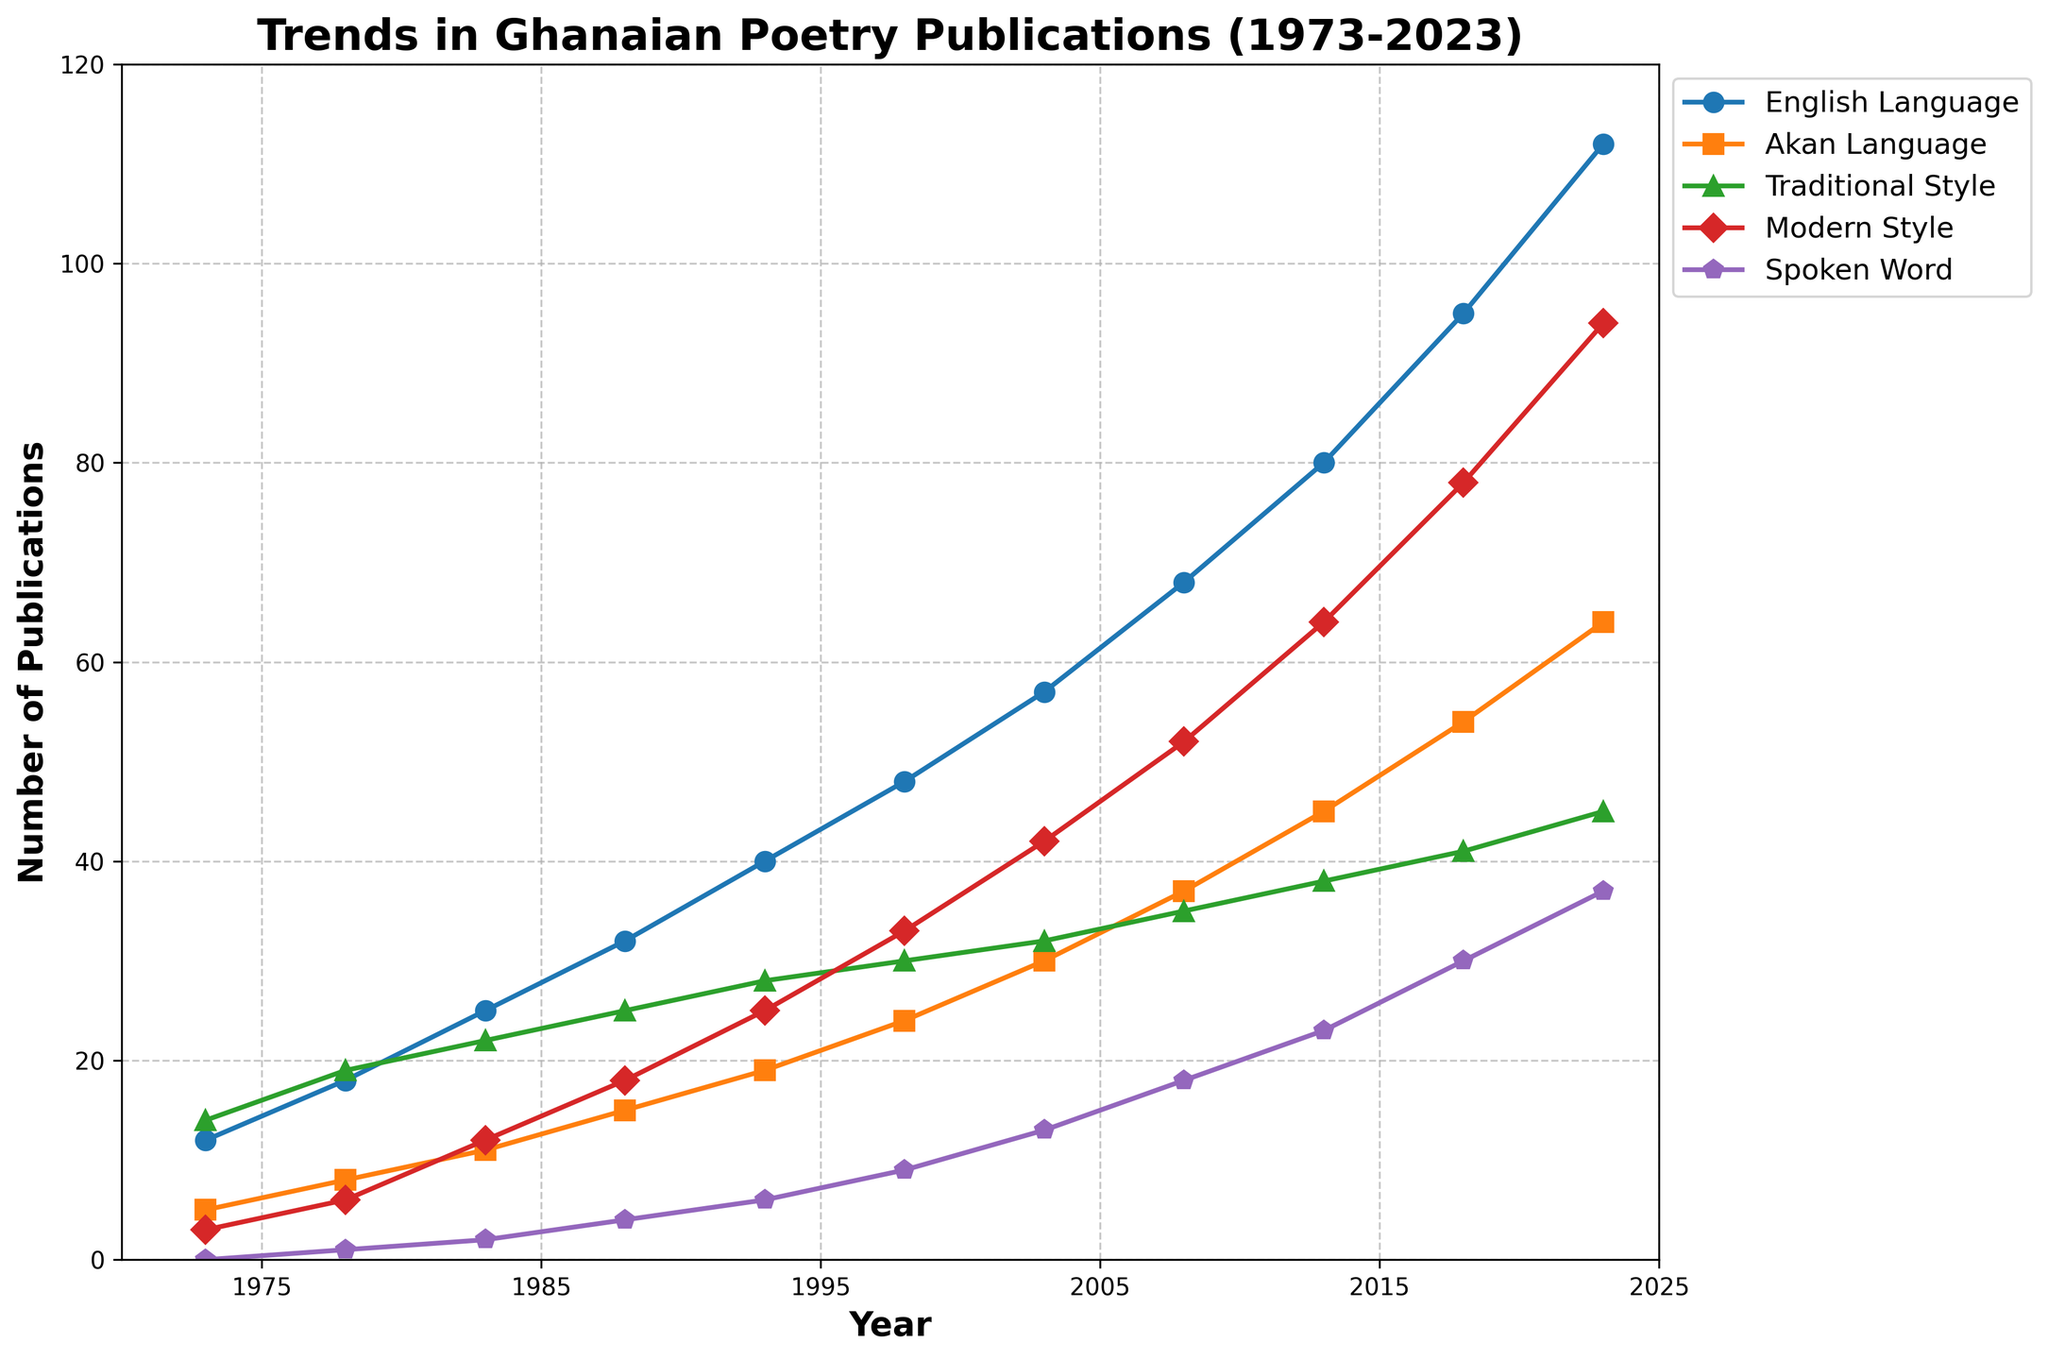What is the trend in the number of poetry publications in English from 1973 to 2023? The number of poetry publications in English shows a consistent increase over time, starting at 12 in 1973 and reaching 112 in 2023.
Answer: Continuous increase In which year did Traditional Style publications first surpass 20? Traditional Style publications surpassed 20 for the first time in 1983 with 22 publications.
Answer: 1983 What’s the difference in the number of Modern Style publications between 1993 and 2003? In 1993, there were 25 Modern Style publications, and in 2003, there were 42. The difference is 42 - 25 = 17.
Answer: 17 Which category had the smallest number of publications in 1978? The Spoken Word category had the smallest number of publications with just 1 in 1978.
Answer: Spoken Word How many more poetry publications in Modern Style were there in 2023 compared to 2013? In 2023, there were 94 Modern Style publications, and in 2013, there were 64. The difference is 94 - 64 = 30.
Answer: 30 In 2018, how many more publications were there in English compared to Akan? In 2018, there were 95 publications in English and 54 in Akan. The difference is 95 - 54 = 41.
Answer: 41 By how much did Spoken Word publications increase from 1973 to 2023? Spoken Word publications were 0 in 1973 and increased to 37 in 2023. The increase is 37 - 0 = 37.
Answer: 37 Which category saw the highest number of publications in 2008? In 2008, Modern Style had the highest number of publications with 52.
Answer: Modern Style 